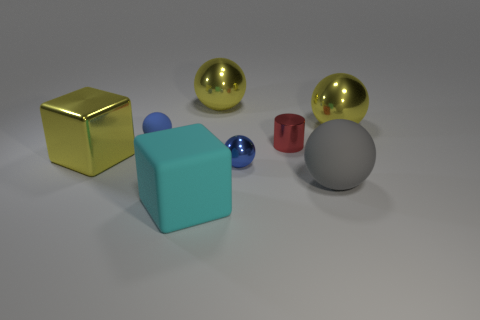Subtract all gray balls. How many balls are left? 4 Subtract all blue metal balls. How many balls are left? 4 Subtract all cyan spheres. Subtract all gray cylinders. How many spheres are left? 5 Add 1 big yellow objects. How many objects exist? 9 Subtract all cubes. How many objects are left? 6 Subtract 0 purple blocks. How many objects are left? 8 Subtract all red rubber cubes. Subtract all metallic blocks. How many objects are left? 7 Add 2 yellow balls. How many yellow balls are left? 4 Add 6 rubber objects. How many rubber objects exist? 9 